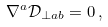Convert formula to latex. <formula><loc_0><loc_0><loc_500><loc_500>\nabla ^ { a } \mathcal { D } _ { \perp a b } = 0 \, ,</formula> 